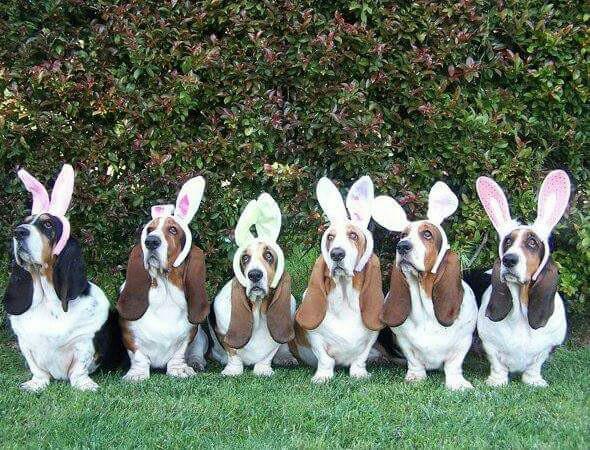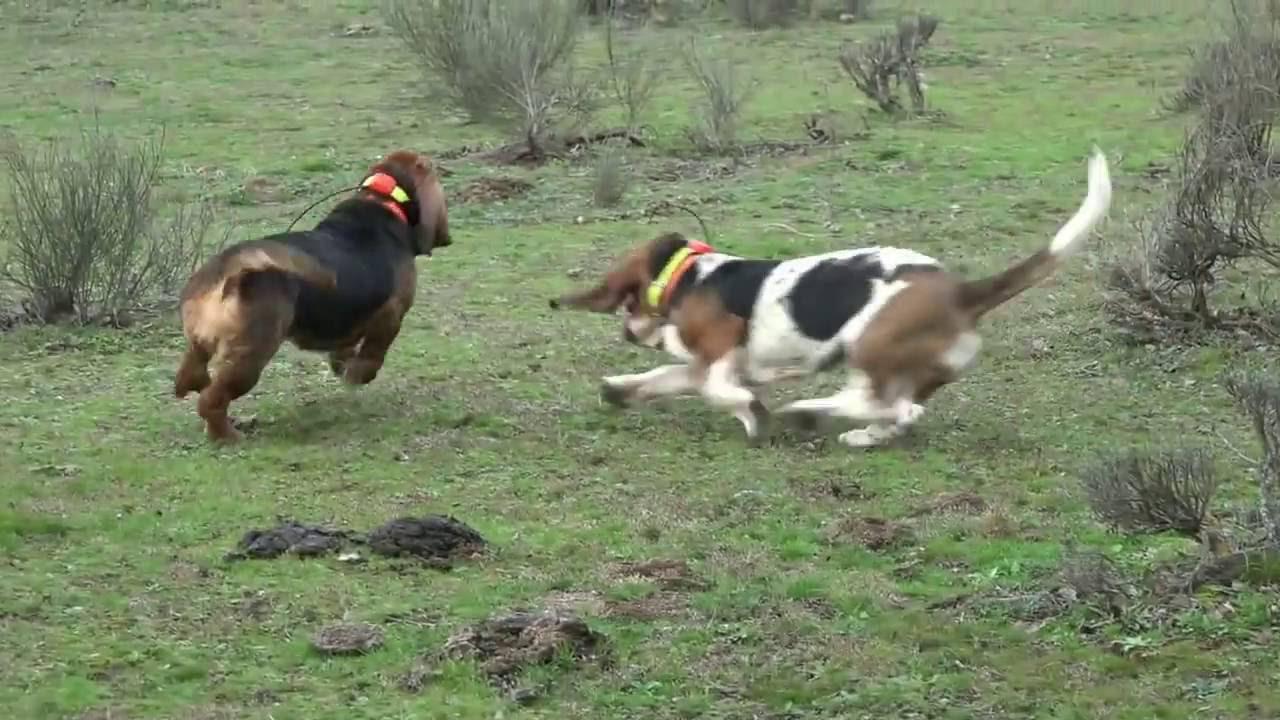The first image is the image on the left, the second image is the image on the right. Given the left and right images, does the statement "All dogs are moving away from the camera in one image." hold true? Answer yes or no. Yes. The first image is the image on the left, the second image is the image on the right. For the images displayed, is the sentence "Dogs are playing in at least one of the images." factually correct? Answer yes or no. Yes. 